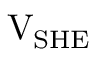Convert formula to latex. <formula><loc_0><loc_0><loc_500><loc_500>V _ { S H E }</formula> 